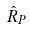Convert formula to latex. <formula><loc_0><loc_0><loc_500><loc_500>\hat { R } _ { P }</formula> 